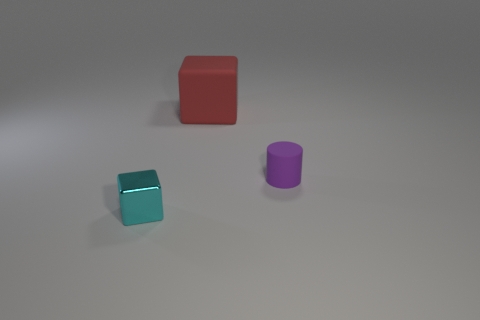Is there any other thing that has the same material as the tiny cube?
Offer a very short reply. No. The object that is both in front of the big thing and behind the cyan metallic cube is what color?
Keep it short and to the point. Purple. How many cubes are big red objects or purple matte things?
Your answer should be compact. 1. Are there fewer large matte cubes that are to the right of the tiny cyan cube than cylinders?
Your response must be concise. No. The small purple object that is made of the same material as the red thing is what shape?
Provide a succinct answer. Cylinder. What number of things are the same color as the small matte cylinder?
Make the answer very short. 0. How many things are either brown metallic cylinders or small objects?
Provide a succinct answer. 2. What material is the big object that is on the left side of the tiny object behind the tiny cyan shiny object?
Your answer should be compact. Rubber. Are there any things made of the same material as the cylinder?
Your answer should be compact. Yes. The object that is on the left side of the object behind the object to the right of the big matte cube is what shape?
Give a very brief answer. Cube. 